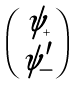Convert formula to latex. <formula><loc_0><loc_0><loc_500><loc_500>\begin{pmatrix} \psi _ { + } \\ \psi ^ { \prime } _ { - } \end{pmatrix}</formula> 